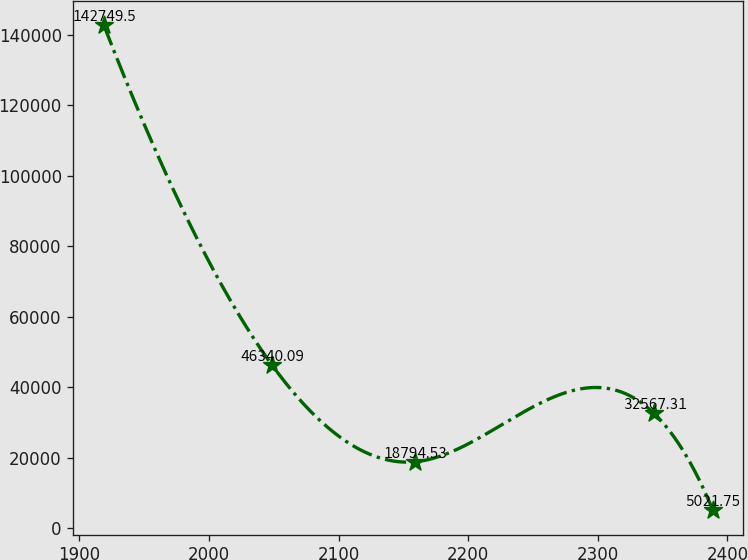Convert chart to OTSL. <chart><loc_0><loc_0><loc_500><loc_500><line_chart><ecel><fcel>Unnamed: 1<nl><fcel>1918.97<fcel>142750<nl><fcel>2048.56<fcel>46340.1<nl><fcel>2158.71<fcel>18794.5<nl><fcel>2343.34<fcel>32567.3<nl><fcel>2388.85<fcel>5021.75<nl></chart> 